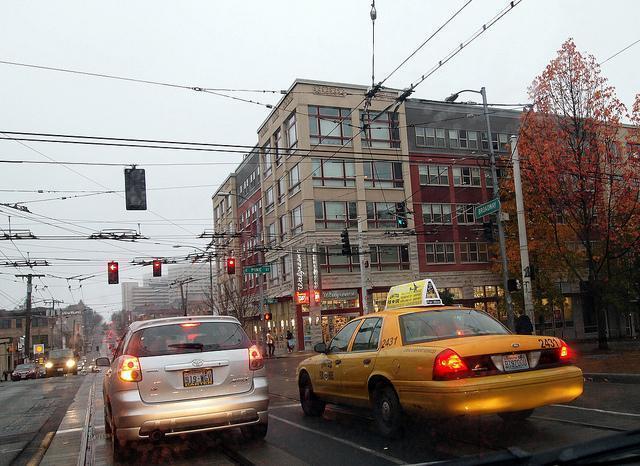How many taxis are there?
Give a very brief answer. 1. How many cars are in the photo?
Give a very brief answer. 2. 